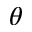Convert formula to latex. <formula><loc_0><loc_0><loc_500><loc_500>\theta</formula> 